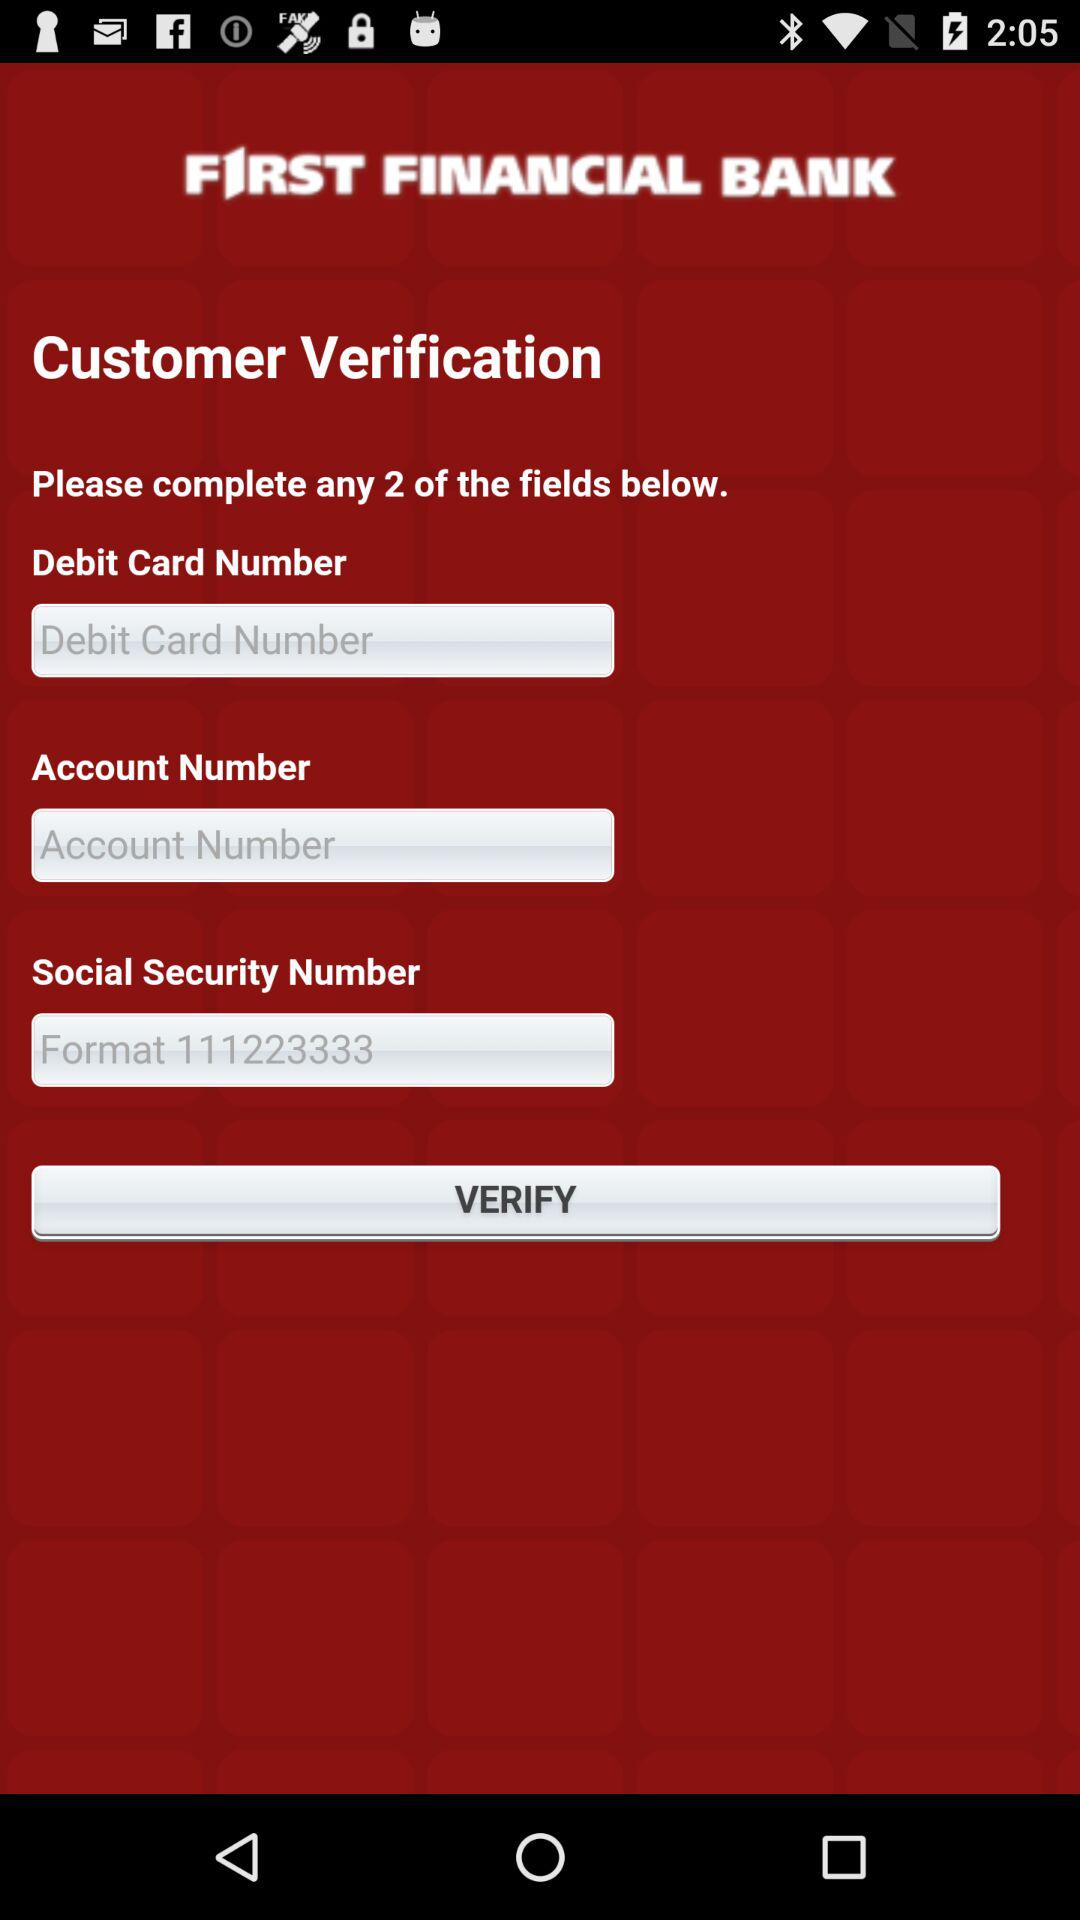What is the name of the application? The application name is "FIRST FINANCIAL BANK". 